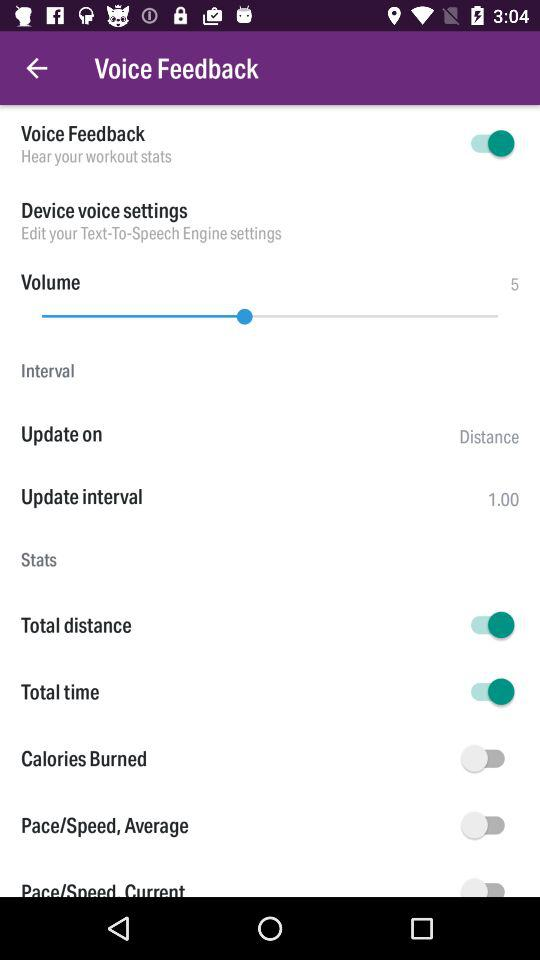What is the status of the total distance? The status is "on". 